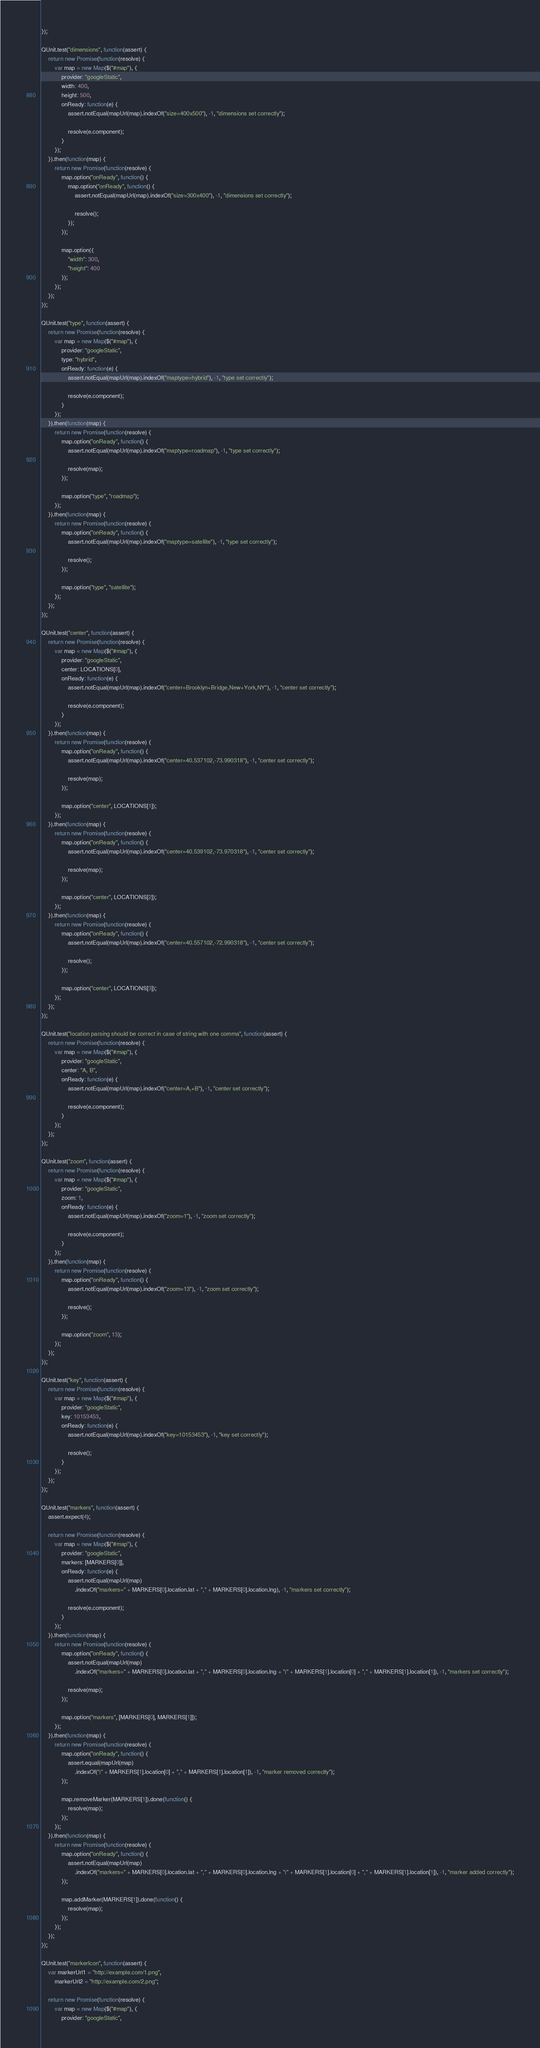<code> <loc_0><loc_0><loc_500><loc_500><_JavaScript_>});

QUnit.test("dimensions", function(assert) {
    return new Promise(function(resolve) {
        var map = new Map($("#map"), {
            provider: "googleStatic",
            width: 400,
            height: 500,
            onReady: function(e) {
                assert.notEqual(mapUrl(map).indexOf("size=400x500"), -1, "dimensions set correctly");

                resolve(e.component);
            }
        });
    }).then(function(map) {
        return new Promise(function(resolve) {
            map.option("onReady", function() {
                map.option("onReady", function() {
                    assert.notEqual(mapUrl(map).indexOf("size=300x400"), -1, "dimensions set correctly");

                    resolve();
                });
            });

            map.option({
                "width": 300,
                "height": 400
            });
        });
    });
});

QUnit.test("type", function(assert) {
    return new Promise(function(resolve) {
        var map = new Map($("#map"), {
            provider: "googleStatic",
            type: "hybrid",
            onReady: function(e) {
                assert.notEqual(mapUrl(map).indexOf("maptype=hybrid"), -1, "type set correctly");

                resolve(e.component);
            }
        });
    }).then(function(map) {
        return new Promise(function(resolve) {
            map.option("onReady", function() {
                assert.notEqual(mapUrl(map).indexOf("maptype=roadmap"), -1, "type set correctly");

                resolve(map);
            });

            map.option("type", "roadmap");
        });
    }).then(function(map) {
        return new Promise(function(resolve) {
            map.option("onReady", function() {
                assert.notEqual(mapUrl(map).indexOf("maptype=satellite"), -1, "type set correctly");

                resolve();
            });

            map.option("type", "satellite");
        });
    });
});

QUnit.test("center", function(assert) {
    return new Promise(function(resolve) {
        var map = new Map($("#map"), {
            provider: "googleStatic",
            center: LOCATIONS[0],
            onReady: function(e) {
                assert.notEqual(mapUrl(map).indexOf("center=Brooklyn+Bridge,New+York,NY"), -1, "center set correctly");

                resolve(e.component);
            }
        });
    }).then(function(map) {
        return new Promise(function(resolve) {
            map.option("onReady", function() {
                assert.notEqual(mapUrl(map).indexOf("center=40.537102,-73.990318"), -1, "center set correctly");

                resolve(map);
            });

            map.option("center", LOCATIONS[1]);
        });
    }).then(function(map) {
        return new Promise(function(resolve) {
            map.option("onReady", function() {
                assert.notEqual(mapUrl(map).indexOf("center=40.539102,-73.970318"), -1, "center set correctly");

                resolve(map);
            });

            map.option("center", LOCATIONS[2]);
        });
    }).then(function(map) {
        return new Promise(function(resolve) {
            map.option("onReady", function() {
                assert.notEqual(mapUrl(map).indexOf("center=40.557102,-72.990318"), -1, "center set correctly");

                resolve();
            });

            map.option("center", LOCATIONS[3]);
        });
    });
});

QUnit.test("location parsing should be correct in case of string with one comma", function(assert) {
    return new Promise(function(resolve) {
        var map = new Map($("#map"), {
            provider: "googleStatic",
            center: "A, B",
            onReady: function(e) {
                assert.notEqual(mapUrl(map).indexOf("center=A,+B"), -1, "center set correctly");

                resolve(e.component);
            }
        });
    });
});

QUnit.test("zoom", function(assert) {
    return new Promise(function(resolve) {
        var map = new Map($("#map"), {
            provider: "googleStatic",
            zoom: 1,
            onReady: function(e) {
                assert.notEqual(mapUrl(map).indexOf("zoom=1"), -1, "zoom set correctly");

                resolve(e.component);
            }
        });
    }).then(function(map) {
        return new Promise(function(resolve) {
            map.option("onReady", function() {
                assert.notEqual(mapUrl(map).indexOf("zoom=13"), -1, "zoom set correctly");

                resolve();
            });

            map.option("zoom", 13);
        });
    });
});

QUnit.test("key", function(assert) {
    return new Promise(function(resolve) {
        var map = new Map($("#map"), {
            provider: "googleStatic",
            key: 10153453,
            onReady: function(e) {
                assert.notEqual(mapUrl(map).indexOf("key=10153453"), -1, "key set correctly");

                resolve();
            }
        });
    });
});

QUnit.test("markers", function(assert) {
    assert.expect(4);

    return new Promise(function(resolve) {
        var map = new Map($("#map"), {
            provider: "googleStatic",
            markers: [MARKERS[0]],
            onReady: function(e) {
                assert.notEqual(mapUrl(map)
                    .indexOf("markers=" + MARKERS[0].location.lat + "," + MARKERS[0].location.lng), -1, "markers set correctly");

                resolve(e.component);
            }
        });
    }).then(function(map) {
        return new Promise(function(resolve) {
            map.option("onReady", function() {
                assert.notEqual(mapUrl(map)
                    .indexOf("markers=" + MARKERS[0].location.lat + "," + MARKERS[0].location.lng + "|" + MARKERS[1].location[0] + "," + MARKERS[1].location[1]), -1, "markers set correctly");

                resolve(map);
            });

            map.option("markers", [MARKERS[0], MARKERS[1]]);
        });
    }).then(function(map) {
        return new Promise(function(resolve) {
            map.option("onReady", function() {
                assert.equal(mapUrl(map)
                    .indexOf("|" + MARKERS[1].location[0] + "," + MARKERS[1].location[1]), -1, "marker removed correctly");
            });

            map.removeMarker(MARKERS[1]).done(function() {
                resolve(map);
            });
        });
    }).then(function(map) {
        return new Promise(function(resolve) {
            map.option("onReady", function() {
                assert.notEqual(mapUrl(map)
                    .indexOf("markers=" + MARKERS[0].location.lat + "," + MARKERS[0].location.lng + "|" + MARKERS[1].location[0] + "," + MARKERS[1].location[1]), -1, "marker added correctly");
            });

            map.addMarker(MARKERS[1]).done(function() {
                resolve(map);
            });
        });
    });
});

QUnit.test("markerIcon", function(assert) {
    var markerUrl1 = "http://example.com/1.png",
        markerUrl2 = "http://example.com/2.png";

    return new Promise(function(resolve) {
        var map = new Map($("#map"), {
            provider: "googleStatic",</code> 